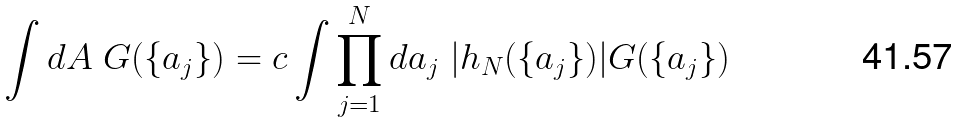Convert formula to latex. <formula><loc_0><loc_0><loc_500><loc_500>\int d A \ G ( \{ a _ { j } \} ) = c \int \prod _ { j = 1 } ^ { N } d a _ { j } \ | h _ { N } ( \{ a _ { j } \} ) | G ( \{ a _ { j } \} )</formula> 